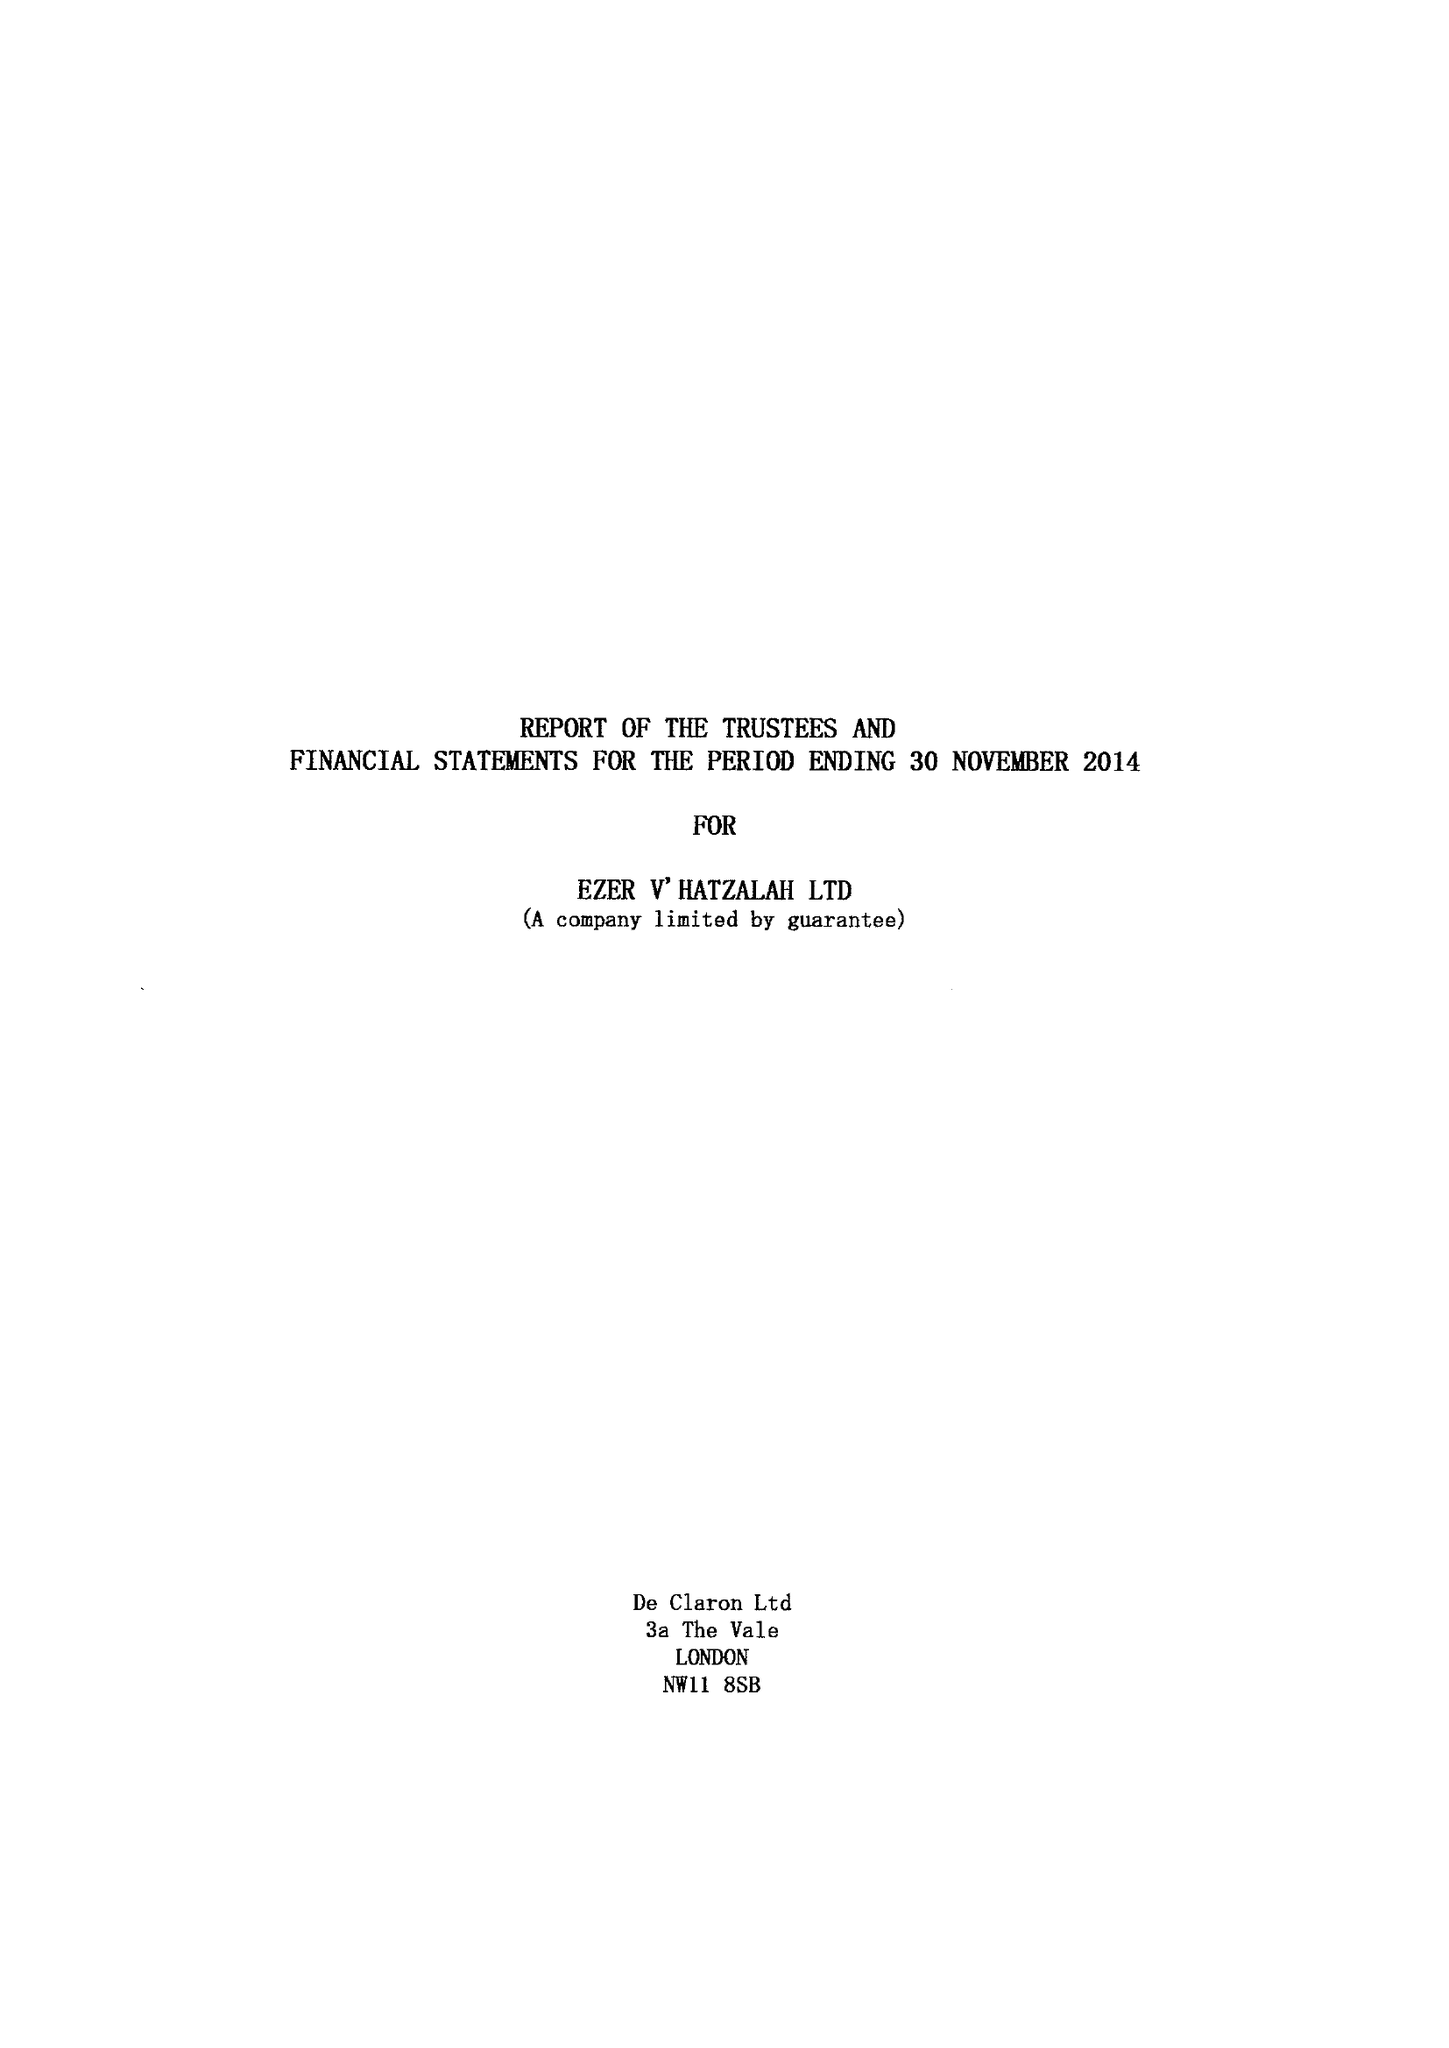What is the value for the spending_annually_in_british_pounds?
Answer the question using a single word or phrase. 8119161.00 